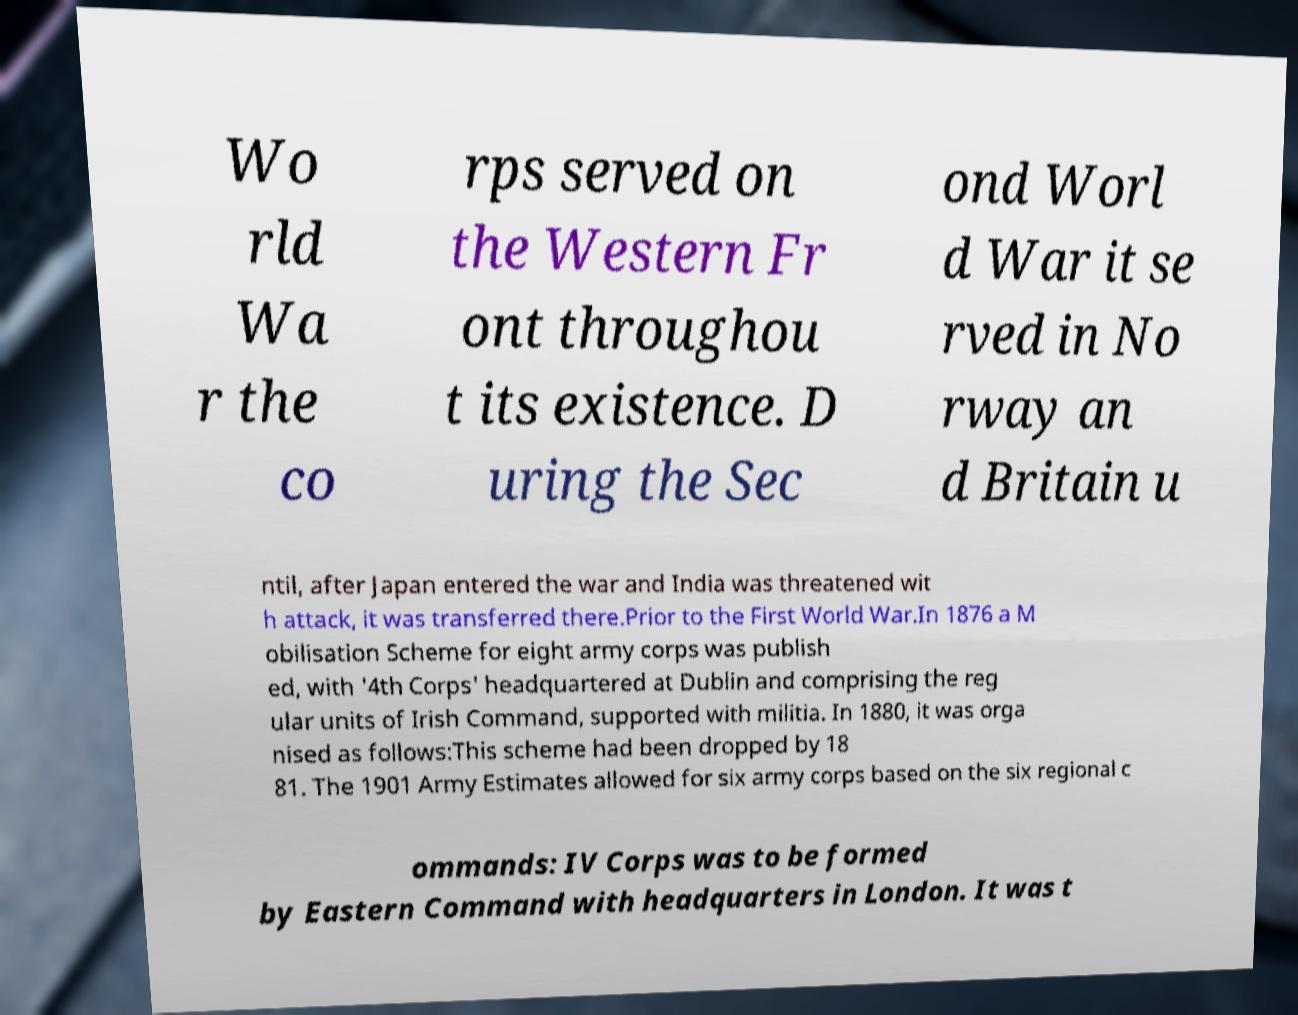What messages or text are displayed in this image? I need them in a readable, typed format. Wo rld Wa r the co rps served on the Western Fr ont throughou t its existence. D uring the Sec ond Worl d War it se rved in No rway an d Britain u ntil, after Japan entered the war and India was threatened wit h attack, it was transferred there.Prior to the First World War.In 1876 a M obilisation Scheme for eight army corps was publish ed, with '4th Corps' headquartered at Dublin and comprising the reg ular units of Irish Command, supported with militia. In 1880, it was orga nised as follows:This scheme had been dropped by 18 81. The 1901 Army Estimates allowed for six army corps based on the six regional c ommands: IV Corps was to be formed by Eastern Command with headquarters in London. It was t 